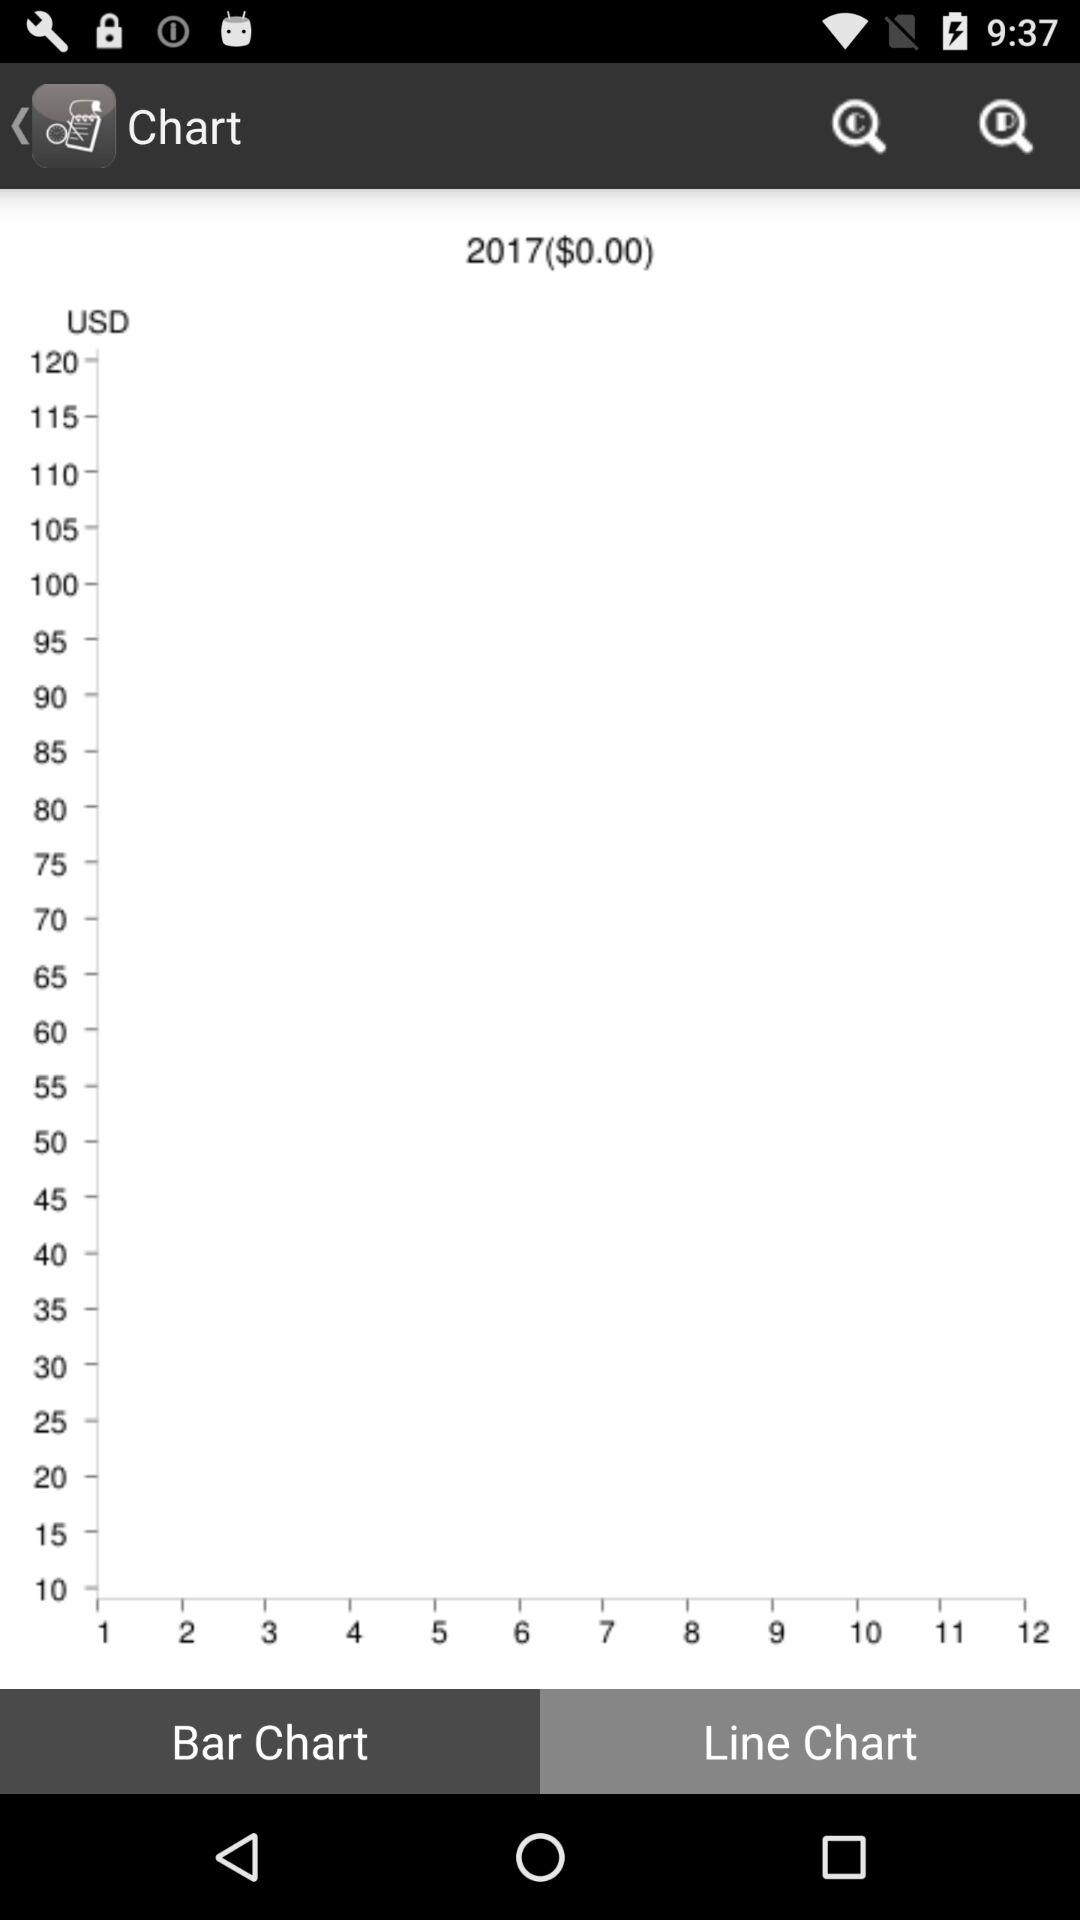Which year is mentioned? The mentioned year is 2017. 